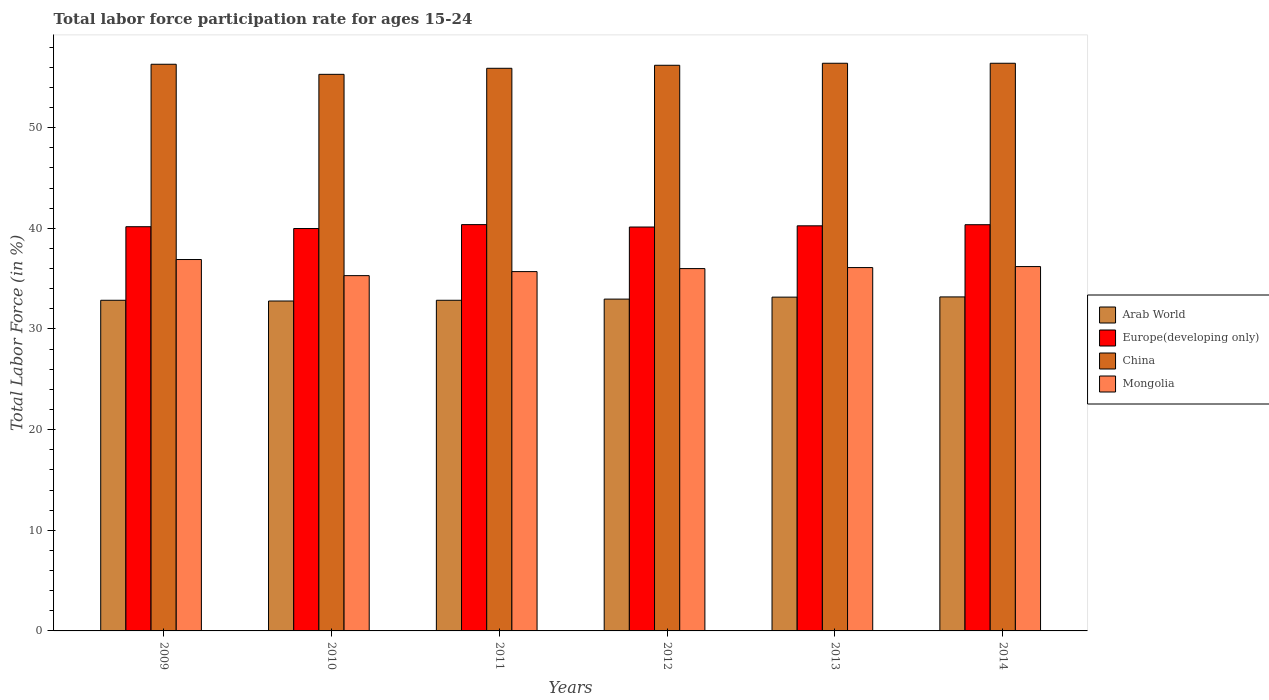How many different coloured bars are there?
Keep it short and to the point. 4. Are the number of bars on each tick of the X-axis equal?
Make the answer very short. Yes. How many bars are there on the 3rd tick from the left?
Keep it short and to the point. 4. What is the labor force participation rate in China in 2010?
Make the answer very short. 55.3. Across all years, what is the maximum labor force participation rate in Mongolia?
Ensure brevity in your answer.  36.9. Across all years, what is the minimum labor force participation rate in Mongolia?
Your response must be concise. 35.3. In which year was the labor force participation rate in China minimum?
Provide a succinct answer. 2010. What is the total labor force participation rate in China in the graph?
Make the answer very short. 336.5. What is the difference between the labor force participation rate in Europe(developing only) in 2009 and that in 2013?
Your response must be concise. -0.09. What is the difference between the labor force participation rate in Arab World in 2010 and the labor force participation rate in Europe(developing only) in 2012?
Provide a succinct answer. -7.35. What is the average labor force participation rate in Europe(developing only) per year?
Offer a very short reply. 40.21. In the year 2014, what is the difference between the labor force participation rate in Mongolia and labor force participation rate in Arab World?
Keep it short and to the point. 3.01. In how many years, is the labor force participation rate in Arab World greater than 14 %?
Make the answer very short. 6. What is the ratio of the labor force participation rate in Europe(developing only) in 2012 to that in 2013?
Keep it short and to the point. 1. Is the difference between the labor force participation rate in Mongolia in 2009 and 2012 greater than the difference between the labor force participation rate in Arab World in 2009 and 2012?
Make the answer very short. Yes. What is the difference between the highest and the second highest labor force participation rate in Europe(developing only)?
Provide a succinct answer. 0.01. What is the difference between the highest and the lowest labor force participation rate in Arab World?
Provide a short and direct response. 0.41. Is the sum of the labor force participation rate in Arab World in 2012 and 2014 greater than the maximum labor force participation rate in Europe(developing only) across all years?
Provide a short and direct response. Yes. What does the 3rd bar from the left in 2012 represents?
Offer a terse response. China. What does the 3rd bar from the right in 2013 represents?
Make the answer very short. Europe(developing only). How many bars are there?
Your response must be concise. 24. What is the title of the graph?
Give a very brief answer. Total labor force participation rate for ages 15-24. Does "Costa Rica" appear as one of the legend labels in the graph?
Offer a terse response. No. What is the label or title of the Y-axis?
Provide a succinct answer. Total Labor Force (in %). What is the Total Labor Force (in %) of Arab World in 2009?
Your answer should be compact. 32.85. What is the Total Labor Force (in %) of Europe(developing only) in 2009?
Make the answer very short. 40.16. What is the Total Labor Force (in %) in China in 2009?
Give a very brief answer. 56.3. What is the Total Labor Force (in %) of Mongolia in 2009?
Provide a succinct answer. 36.9. What is the Total Labor Force (in %) in Arab World in 2010?
Keep it short and to the point. 32.78. What is the Total Labor Force (in %) in Europe(developing only) in 2010?
Your answer should be very brief. 39.98. What is the Total Labor Force (in %) of China in 2010?
Your answer should be compact. 55.3. What is the Total Labor Force (in %) of Mongolia in 2010?
Provide a short and direct response. 35.3. What is the Total Labor Force (in %) of Arab World in 2011?
Ensure brevity in your answer.  32.85. What is the Total Labor Force (in %) of Europe(developing only) in 2011?
Ensure brevity in your answer.  40.37. What is the Total Labor Force (in %) of China in 2011?
Your answer should be compact. 55.9. What is the Total Labor Force (in %) of Mongolia in 2011?
Provide a succinct answer. 35.7. What is the Total Labor Force (in %) in Arab World in 2012?
Your response must be concise. 32.97. What is the Total Labor Force (in %) in Europe(developing only) in 2012?
Your answer should be very brief. 40.13. What is the Total Labor Force (in %) of China in 2012?
Your answer should be compact. 56.2. What is the Total Labor Force (in %) in Arab World in 2013?
Give a very brief answer. 33.16. What is the Total Labor Force (in %) of Europe(developing only) in 2013?
Ensure brevity in your answer.  40.25. What is the Total Labor Force (in %) in China in 2013?
Keep it short and to the point. 56.4. What is the Total Labor Force (in %) in Mongolia in 2013?
Make the answer very short. 36.1. What is the Total Labor Force (in %) of Arab World in 2014?
Make the answer very short. 33.19. What is the Total Labor Force (in %) of Europe(developing only) in 2014?
Provide a short and direct response. 40.36. What is the Total Labor Force (in %) of China in 2014?
Provide a short and direct response. 56.4. What is the Total Labor Force (in %) in Mongolia in 2014?
Give a very brief answer. 36.2. Across all years, what is the maximum Total Labor Force (in %) of Arab World?
Give a very brief answer. 33.19. Across all years, what is the maximum Total Labor Force (in %) in Europe(developing only)?
Give a very brief answer. 40.37. Across all years, what is the maximum Total Labor Force (in %) in China?
Provide a succinct answer. 56.4. Across all years, what is the maximum Total Labor Force (in %) in Mongolia?
Keep it short and to the point. 36.9. Across all years, what is the minimum Total Labor Force (in %) in Arab World?
Offer a terse response. 32.78. Across all years, what is the minimum Total Labor Force (in %) in Europe(developing only)?
Give a very brief answer. 39.98. Across all years, what is the minimum Total Labor Force (in %) in China?
Give a very brief answer. 55.3. Across all years, what is the minimum Total Labor Force (in %) of Mongolia?
Give a very brief answer. 35.3. What is the total Total Labor Force (in %) in Arab World in the graph?
Keep it short and to the point. 197.8. What is the total Total Labor Force (in %) of Europe(developing only) in the graph?
Give a very brief answer. 241.25. What is the total Total Labor Force (in %) of China in the graph?
Keep it short and to the point. 336.5. What is the total Total Labor Force (in %) in Mongolia in the graph?
Keep it short and to the point. 216.2. What is the difference between the Total Labor Force (in %) in Arab World in 2009 and that in 2010?
Ensure brevity in your answer.  0.07. What is the difference between the Total Labor Force (in %) of Europe(developing only) in 2009 and that in 2010?
Provide a succinct answer. 0.18. What is the difference between the Total Labor Force (in %) in China in 2009 and that in 2010?
Your answer should be very brief. 1. What is the difference between the Total Labor Force (in %) in Mongolia in 2009 and that in 2010?
Your response must be concise. 1.6. What is the difference between the Total Labor Force (in %) in Arab World in 2009 and that in 2011?
Provide a short and direct response. 0. What is the difference between the Total Labor Force (in %) of Europe(developing only) in 2009 and that in 2011?
Your response must be concise. -0.21. What is the difference between the Total Labor Force (in %) in Arab World in 2009 and that in 2012?
Offer a very short reply. -0.12. What is the difference between the Total Labor Force (in %) of Europe(developing only) in 2009 and that in 2012?
Your answer should be compact. 0.03. What is the difference between the Total Labor Force (in %) of China in 2009 and that in 2012?
Your answer should be compact. 0.1. What is the difference between the Total Labor Force (in %) in Mongolia in 2009 and that in 2012?
Ensure brevity in your answer.  0.9. What is the difference between the Total Labor Force (in %) of Arab World in 2009 and that in 2013?
Offer a very short reply. -0.31. What is the difference between the Total Labor Force (in %) of Europe(developing only) in 2009 and that in 2013?
Offer a terse response. -0.09. What is the difference between the Total Labor Force (in %) of Arab World in 2009 and that in 2014?
Give a very brief answer. -0.33. What is the difference between the Total Labor Force (in %) of Europe(developing only) in 2009 and that in 2014?
Offer a terse response. -0.2. What is the difference between the Total Labor Force (in %) in Arab World in 2010 and that in 2011?
Give a very brief answer. -0.07. What is the difference between the Total Labor Force (in %) in Europe(developing only) in 2010 and that in 2011?
Give a very brief answer. -0.39. What is the difference between the Total Labor Force (in %) in Mongolia in 2010 and that in 2011?
Provide a succinct answer. -0.4. What is the difference between the Total Labor Force (in %) in Arab World in 2010 and that in 2012?
Your response must be concise. -0.19. What is the difference between the Total Labor Force (in %) in Europe(developing only) in 2010 and that in 2012?
Keep it short and to the point. -0.15. What is the difference between the Total Labor Force (in %) in China in 2010 and that in 2012?
Provide a short and direct response. -0.9. What is the difference between the Total Labor Force (in %) of Mongolia in 2010 and that in 2012?
Make the answer very short. -0.7. What is the difference between the Total Labor Force (in %) of Arab World in 2010 and that in 2013?
Provide a short and direct response. -0.39. What is the difference between the Total Labor Force (in %) of Europe(developing only) in 2010 and that in 2013?
Provide a succinct answer. -0.27. What is the difference between the Total Labor Force (in %) in Arab World in 2010 and that in 2014?
Make the answer very short. -0.41. What is the difference between the Total Labor Force (in %) in Europe(developing only) in 2010 and that in 2014?
Your response must be concise. -0.38. What is the difference between the Total Labor Force (in %) of Mongolia in 2010 and that in 2014?
Keep it short and to the point. -0.9. What is the difference between the Total Labor Force (in %) in Arab World in 2011 and that in 2012?
Your answer should be compact. -0.12. What is the difference between the Total Labor Force (in %) in Europe(developing only) in 2011 and that in 2012?
Offer a terse response. 0.24. What is the difference between the Total Labor Force (in %) of Arab World in 2011 and that in 2013?
Make the answer very short. -0.31. What is the difference between the Total Labor Force (in %) of Europe(developing only) in 2011 and that in 2013?
Ensure brevity in your answer.  0.12. What is the difference between the Total Labor Force (in %) of China in 2011 and that in 2013?
Your answer should be compact. -0.5. What is the difference between the Total Labor Force (in %) of Arab World in 2011 and that in 2014?
Give a very brief answer. -0.33. What is the difference between the Total Labor Force (in %) of Europe(developing only) in 2011 and that in 2014?
Your answer should be compact. 0.01. What is the difference between the Total Labor Force (in %) in Mongolia in 2011 and that in 2014?
Provide a succinct answer. -0.5. What is the difference between the Total Labor Force (in %) in Arab World in 2012 and that in 2013?
Give a very brief answer. -0.2. What is the difference between the Total Labor Force (in %) in Europe(developing only) in 2012 and that in 2013?
Offer a terse response. -0.12. What is the difference between the Total Labor Force (in %) in China in 2012 and that in 2013?
Ensure brevity in your answer.  -0.2. What is the difference between the Total Labor Force (in %) in Arab World in 2012 and that in 2014?
Ensure brevity in your answer.  -0.22. What is the difference between the Total Labor Force (in %) in Europe(developing only) in 2012 and that in 2014?
Keep it short and to the point. -0.23. What is the difference between the Total Labor Force (in %) of Arab World in 2013 and that in 2014?
Offer a terse response. -0.02. What is the difference between the Total Labor Force (in %) of Europe(developing only) in 2013 and that in 2014?
Give a very brief answer. -0.11. What is the difference between the Total Labor Force (in %) of China in 2013 and that in 2014?
Keep it short and to the point. 0. What is the difference between the Total Labor Force (in %) in Arab World in 2009 and the Total Labor Force (in %) in Europe(developing only) in 2010?
Keep it short and to the point. -7.13. What is the difference between the Total Labor Force (in %) of Arab World in 2009 and the Total Labor Force (in %) of China in 2010?
Provide a succinct answer. -22.45. What is the difference between the Total Labor Force (in %) of Arab World in 2009 and the Total Labor Force (in %) of Mongolia in 2010?
Provide a short and direct response. -2.45. What is the difference between the Total Labor Force (in %) in Europe(developing only) in 2009 and the Total Labor Force (in %) in China in 2010?
Give a very brief answer. -15.14. What is the difference between the Total Labor Force (in %) in Europe(developing only) in 2009 and the Total Labor Force (in %) in Mongolia in 2010?
Offer a terse response. 4.86. What is the difference between the Total Labor Force (in %) in Arab World in 2009 and the Total Labor Force (in %) in Europe(developing only) in 2011?
Offer a terse response. -7.52. What is the difference between the Total Labor Force (in %) in Arab World in 2009 and the Total Labor Force (in %) in China in 2011?
Provide a succinct answer. -23.05. What is the difference between the Total Labor Force (in %) in Arab World in 2009 and the Total Labor Force (in %) in Mongolia in 2011?
Your answer should be very brief. -2.85. What is the difference between the Total Labor Force (in %) in Europe(developing only) in 2009 and the Total Labor Force (in %) in China in 2011?
Provide a short and direct response. -15.74. What is the difference between the Total Labor Force (in %) of Europe(developing only) in 2009 and the Total Labor Force (in %) of Mongolia in 2011?
Keep it short and to the point. 4.46. What is the difference between the Total Labor Force (in %) in China in 2009 and the Total Labor Force (in %) in Mongolia in 2011?
Provide a succinct answer. 20.6. What is the difference between the Total Labor Force (in %) in Arab World in 2009 and the Total Labor Force (in %) in Europe(developing only) in 2012?
Your answer should be compact. -7.28. What is the difference between the Total Labor Force (in %) in Arab World in 2009 and the Total Labor Force (in %) in China in 2012?
Offer a terse response. -23.35. What is the difference between the Total Labor Force (in %) of Arab World in 2009 and the Total Labor Force (in %) of Mongolia in 2012?
Your response must be concise. -3.15. What is the difference between the Total Labor Force (in %) of Europe(developing only) in 2009 and the Total Labor Force (in %) of China in 2012?
Offer a very short reply. -16.04. What is the difference between the Total Labor Force (in %) in Europe(developing only) in 2009 and the Total Labor Force (in %) in Mongolia in 2012?
Your answer should be compact. 4.16. What is the difference between the Total Labor Force (in %) in China in 2009 and the Total Labor Force (in %) in Mongolia in 2012?
Your response must be concise. 20.3. What is the difference between the Total Labor Force (in %) in Arab World in 2009 and the Total Labor Force (in %) in Europe(developing only) in 2013?
Offer a very short reply. -7.4. What is the difference between the Total Labor Force (in %) in Arab World in 2009 and the Total Labor Force (in %) in China in 2013?
Make the answer very short. -23.55. What is the difference between the Total Labor Force (in %) in Arab World in 2009 and the Total Labor Force (in %) in Mongolia in 2013?
Your response must be concise. -3.25. What is the difference between the Total Labor Force (in %) of Europe(developing only) in 2009 and the Total Labor Force (in %) of China in 2013?
Keep it short and to the point. -16.24. What is the difference between the Total Labor Force (in %) in Europe(developing only) in 2009 and the Total Labor Force (in %) in Mongolia in 2013?
Provide a short and direct response. 4.06. What is the difference between the Total Labor Force (in %) of China in 2009 and the Total Labor Force (in %) of Mongolia in 2013?
Make the answer very short. 20.2. What is the difference between the Total Labor Force (in %) in Arab World in 2009 and the Total Labor Force (in %) in Europe(developing only) in 2014?
Make the answer very short. -7.51. What is the difference between the Total Labor Force (in %) in Arab World in 2009 and the Total Labor Force (in %) in China in 2014?
Give a very brief answer. -23.55. What is the difference between the Total Labor Force (in %) in Arab World in 2009 and the Total Labor Force (in %) in Mongolia in 2014?
Provide a short and direct response. -3.35. What is the difference between the Total Labor Force (in %) in Europe(developing only) in 2009 and the Total Labor Force (in %) in China in 2014?
Your answer should be very brief. -16.24. What is the difference between the Total Labor Force (in %) of Europe(developing only) in 2009 and the Total Labor Force (in %) of Mongolia in 2014?
Ensure brevity in your answer.  3.96. What is the difference between the Total Labor Force (in %) in China in 2009 and the Total Labor Force (in %) in Mongolia in 2014?
Ensure brevity in your answer.  20.1. What is the difference between the Total Labor Force (in %) of Arab World in 2010 and the Total Labor Force (in %) of Europe(developing only) in 2011?
Your answer should be compact. -7.59. What is the difference between the Total Labor Force (in %) of Arab World in 2010 and the Total Labor Force (in %) of China in 2011?
Offer a very short reply. -23.12. What is the difference between the Total Labor Force (in %) of Arab World in 2010 and the Total Labor Force (in %) of Mongolia in 2011?
Keep it short and to the point. -2.92. What is the difference between the Total Labor Force (in %) of Europe(developing only) in 2010 and the Total Labor Force (in %) of China in 2011?
Your answer should be very brief. -15.92. What is the difference between the Total Labor Force (in %) of Europe(developing only) in 2010 and the Total Labor Force (in %) of Mongolia in 2011?
Ensure brevity in your answer.  4.28. What is the difference between the Total Labor Force (in %) of China in 2010 and the Total Labor Force (in %) of Mongolia in 2011?
Offer a terse response. 19.6. What is the difference between the Total Labor Force (in %) of Arab World in 2010 and the Total Labor Force (in %) of Europe(developing only) in 2012?
Make the answer very short. -7.35. What is the difference between the Total Labor Force (in %) in Arab World in 2010 and the Total Labor Force (in %) in China in 2012?
Your answer should be compact. -23.42. What is the difference between the Total Labor Force (in %) in Arab World in 2010 and the Total Labor Force (in %) in Mongolia in 2012?
Offer a terse response. -3.22. What is the difference between the Total Labor Force (in %) in Europe(developing only) in 2010 and the Total Labor Force (in %) in China in 2012?
Your answer should be compact. -16.22. What is the difference between the Total Labor Force (in %) in Europe(developing only) in 2010 and the Total Labor Force (in %) in Mongolia in 2012?
Ensure brevity in your answer.  3.98. What is the difference between the Total Labor Force (in %) in China in 2010 and the Total Labor Force (in %) in Mongolia in 2012?
Your answer should be compact. 19.3. What is the difference between the Total Labor Force (in %) in Arab World in 2010 and the Total Labor Force (in %) in Europe(developing only) in 2013?
Offer a very short reply. -7.47. What is the difference between the Total Labor Force (in %) of Arab World in 2010 and the Total Labor Force (in %) of China in 2013?
Keep it short and to the point. -23.62. What is the difference between the Total Labor Force (in %) of Arab World in 2010 and the Total Labor Force (in %) of Mongolia in 2013?
Offer a terse response. -3.32. What is the difference between the Total Labor Force (in %) in Europe(developing only) in 2010 and the Total Labor Force (in %) in China in 2013?
Offer a terse response. -16.42. What is the difference between the Total Labor Force (in %) in Europe(developing only) in 2010 and the Total Labor Force (in %) in Mongolia in 2013?
Offer a terse response. 3.88. What is the difference between the Total Labor Force (in %) in China in 2010 and the Total Labor Force (in %) in Mongolia in 2013?
Provide a succinct answer. 19.2. What is the difference between the Total Labor Force (in %) of Arab World in 2010 and the Total Labor Force (in %) of Europe(developing only) in 2014?
Your answer should be very brief. -7.58. What is the difference between the Total Labor Force (in %) in Arab World in 2010 and the Total Labor Force (in %) in China in 2014?
Offer a very short reply. -23.62. What is the difference between the Total Labor Force (in %) in Arab World in 2010 and the Total Labor Force (in %) in Mongolia in 2014?
Your answer should be compact. -3.42. What is the difference between the Total Labor Force (in %) in Europe(developing only) in 2010 and the Total Labor Force (in %) in China in 2014?
Offer a terse response. -16.42. What is the difference between the Total Labor Force (in %) of Europe(developing only) in 2010 and the Total Labor Force (in %) of Mongolia in 2014?
Offer a terse response. 3.78. What is the difference between the Total Labor Force (in %) of Arab World in 2011 and the Total Labor Force (in %) of Europe(developing only) in 2012?
Your answer should be compact. -7.28. What is the difference between the Total Labor Force (in %) in Arab World in 2011 and the Total Labor Force (in %) in China in 2012?
Provide a succinct answer. -23.35. What is the difference between the Total Labor Force (in %) of Arab World in 2011 and the Total Labor Force (in %) of Mongolia in 2012?
Provide a short and direct response. -3.15. What is the difference between the Total Labor Force (in %) of Europe(developing only) in 2011 and the Total Labor Force (in %) of China in 2012?
Your response must be concise. -15.83. What is the difference between the Total Labor Force (in %) of Europe(developing only) in 2011 and the Total Labor Force (in %) of Mongolia in 2012?
Provide a succinct answer. 4.37. What is the difference between the Total Labor Force (in %) of Arab World in 2011 and the Total Labor Force (in %) of Europe(developing only) in 2013?
Make the answer very short. -7.4. What is the difference between the Total Labor Force (in %) in Arab World in 2011 and the Total Labor Force (in %) in China in 2013?
Provide a short and direct response. -23.55. What is the difference between the Total Labor Force (in %) of Arab World in 2011 and the Total Labor Force (in %) of Mongolia in 2013?
Keep it short and to the point. -3.25. What is the difference between the Total Labor Force (in %) of Europe(developing only) in 2011 and the Total Labor Force (in %) of China in 2013?
Give a very brief answer. -16.03. What is the difference between the Total Labor Force (in %) of Europe(developing only) in 2011 and the Total Labor Force (in %) of Mongolia in 2013?
Make the answer very short. 4.27. What is the difference between the Total Labor Force (in %) of China in 2011 and the Total Labor Force (in %) of Mongolia in 2013?
Keep it short and to the point. 19.8. What is the difference between the Total Labor Force (in %) in Arab World in 2011 and the Total Labor Force (in %) in Europe(developing only) in 2014?
Keep it short and to the point. -7.51. What is the difference between the Total Labor Force (in %) in Arab World in 2011 and the Total Labor Force (in %) in China in 2014?
Ensure brevity in your answer.  -23.55. What is the difference between the Total Labor Force (in %) of Arab World in 2011 and the Total Labor Force (in %) of Mongolia in 2014?
Offer a terse response. -3.35. What is the difference between the Total Labor Force (in %) in Europe(developing only) in 2011 and the Total Labor Force (in %) in China in 2014?
Your response must be concise. -16.03. What is the difference between the Total Labor Force (in %) in Europe(developing only) in 2011 and the Total Labor Force (in %) in Mongolia in 2014?
Ensure brevity in your answer.  4.17. What is the difference between the Total Labor Force (in %) in China in 2011 and the Total Labor Force (in %) in Mongolia in 2014?
Provide a succinct answer. 19.7. What is the difference between the Total Labor Force (in %) in Arab World in 2012 and the Total Labor Force (in %) in Europe(developing only) in 2013?
Offer a terse response. -7.28. What is the difference between the Total Labor Force (in %) of Arab World in 2012 and the Total Labor Force (in %) of China in 2013?
Give a very brief answer. -23.43. What is the difference between the Total Labor Force (in %) of Arab World in 2012 and the Total Labor Force (in %) of Mongolia in 2013?
Offer a very short reply. -3.13. What is the difference between the Total Labor Force (in %) in Europe(developing only) in 2012 and the Total Labor Force (in %) in China in 2013?
Offer a terse response. -16.27. What is the difference between the Total Labor Force (in %) in Europe(developing only) in 2012 and the Total Labor Force (in %) in Mongolia in 2013?
Your response must be concise. 4.03. What is the difference between the Total Labor Force (in %) in China in 2012 and the Total Labor Force (in %) in Mongolia in 2013?
Provide a short and direct response. 20.1. What is the difference between the Total Labor Force (in %) of Arab World in 2012 and the Total Labor Force (in %) of Europe(developing only) in 2014?
Keep it short and to the point. -7.39. What is the difference between the Total Labor Force (in %) of Arab World in 2012 and the Total Labor Force (in %) of China in 2014?
Make the answer very short. -23.43. What is the difference between the Total Labor Force (in %) of Arab World in 2012 and the Total Labor Force (in %) of Mongolia in 2014?
Your answer should be very brief. -3.23. What is the difference between the Total Labor Force (in %) in Europe(developing only) in 2012 and the Total Labor Force (in %) in China in 2014?
Provide a short and direct response. -16.27. What is the difference between the Total Labor Force (in %) of Europe(developing only) in 2012 and the Total Labor Force (in %) of Mongolia in 2014?
Provide a succinct answer. 3.93. What is the difference between the Total Labor Force (in %) of Arab World in 2013 and the Total Labor Force (in %) of Europe(developing only) in 2014?
Offer a very short reply. -7.19. What is the difference between the Total Labor Force (in %) of Arab World in 2013 and the Total Labor Force (in %) of China in 2014?
Provide a succinct answer. -23.24. What is the difference between the Total Labor Force (in %) of Arab World in 2013 and the Total Labor Force (in %) of Mongolia in 2014?
Ensure brevity in your answer.  -3.04. What is the difference between the Total Labor Force (in %) of Europe(developing only) in 2013 and the Total Labor Force (in %) of China in 2014?
Keep it short and to the point. -16.15. What is the difference between the Total Labor Force (in %) in Europe(developing only) in 2013 and the Total Labor Force (in %) in Mongolia in 2014?
Your answer should be very brief. 4.05. What is the difference between the Total Labor Force (in %) in China in 2013 and the Total Labor Force (in %) in Mongolia in 2014?
Your response must be concise. 20.2. What is the average Total Labor Force (in %) in Arab World per year?
Your answer should be very brief. 32.97. What is the average Total Labor Force (in %) in Europe(developing only) per year?
Your answer should be compact. 40.21. What is the average Total Labor Force (in %) of China per year?
Offer a terse response. 56.08. What is the average Total Labor Force (in %) in Mongolia per year?
Keep it short and to the point. 36.03. In the year 2009, what is the difference between the Total Labor Force (in %) of Arab World and Total Labor Force (in %) of Europe(developing only)?
Your answer should be very brief. -7.31. In the year 2009, what is the difference between the Total Labor Force (in %) of Arab World and Total Labor Force (in %) of China?
Your answer should be very brief. -23.45. In the year 2009, what is the difference between the Total Labor Force (in %) of Arab World and Total Labor Force (in %) of Mongolia?
Give a very brief answer. -4.05. In the year 2009, what is the difference between the Total Labor Force (in %) of Europe(developing only) and Total Labor Force (in %) of China?
Offer a very short reply. -16.14. In the year 2009, what is the difference between the Total Labor Force (in %) in Europe(developing only) and Total Labor Force (in %) in Mongolia?
Offer a terse response. 3.26. In the year 2010, what is the difference between the Total Labor Force (in %) in Arab World and Total Labor Force (in %) in Europe(developing only)?
Ensure brevity in your answer.  -7.2. In the year 2010, what is the difference between the Total Labor Force (in %) of Arab World and Total Labor Force (in %) of China?
Your response must be concise. -22.52. In the year 2010, what is the difference between the Total Labor Force (in %) in Arab World and Total Labor Force (in %) in Mongolia?
Your answer should be very brief. -2.52. In the year 2010, what is the difference between the Total Labor Force (in %) in Europe(developing only) and Total Labor Force (in %) in China?
Make the answer very short. -15.32. In the year 2010, what is the difference between the Total Labor Force (in %) of Europe(developing only) and Total Labor Force (in %) of Mongolia?
Give a very brief answer. 4.68. In the year 2010, what is the difference between the Total Labor Force (in %) of China and Total Labor Force (in %) of Mongolia?
Provide a succinct answer. 20. In the year 2011, what is the difference between the Total Labor Force (in %) of Arab World and Total Labor Force (in %) of Europe(developing only)?
Give a very brief answer. -7.52. In the year 2011, what is the difference between the Total Labor Force (in %) in Arab World and Total Labor Force (in %) in China?
Give a very brief answer. -23.05. In the year 2011, what is the difference between the Total Labor Force (in %) in Arab World and Total Labor Force (in %) in Mongolia?
Provide a short and direct response. -2.85. In the year 2011, what is the difference between the Total Labor Force (in %) of Europe(developing only) and Total Labor Force (in %) of China?
Your answer should be compact. -15.53. In the year 2011, what is the difference between the Total Labor Force (in %) of Europe(developing only) and Total Labor Force (in %) of Mongolia?
Provide a succinct answer. 4.67. In the year 2011, what is the difference between the Total Labor Force (in %) of China and Total Labor Force (in %) of Mongolia?
Provide a succinct answer. 20.2. In the year 2012, what is the difference between the Total Labor Force (in %) in Arab World and Total Labor Force (in %) in Europe(developing only)?
Offer a very short reply. -7.16. In the year 2012, what is the difference between the Total Labor Force (in %) in Arab World and Total Labor Force (in %) in China?
Your response must be concise. -23.23. In the year 2012, what is the difference between the Total Labor Force (in %) of Arab World and Total Labor Force (in %) of Mongolia?
Ensure brevity in your answer.  -3.03. In the year 2012, what is the difference between the Total Labor Force (in %) of Europe(developing only) and Total Labor Force (in %) of China?
Your answer should be compact. -16.07. In the year 2012, what is the difference between the Total Labor Force (in %) in Europe(developing only) and Total Labor Force (in %) in Mongolia?
Offer a terse response. 4.13. In the year 2012, what is the difference between the Total Labor Force (in %) of China and Total Labor Force (in %) of Mongolia?
Make the answer very short. 20.2. In the year 2013, what is the difference between the Total Labor Force (in %) in Arab World and Total Labor Force (in %) in Europe(developing only)?
Make the answer very short. -7.09. In the year 2013, what is the difference between the Total Labor Force (in %) of Arab World and Total Labor Force (in %) of China?
Provide a succinct answer. -23.24. In the year 2013, what is the difference between the Total Labor Force (in %) of Arab World and Total Labor Force (in %) of Mongolia?
Your answer should be compact. -2.94. In the year 2013, what is the difference between the Total Labor Force (in %) of Europe(developing only) and Total Labor Force (in %) of China?
Give a very brief answer. -16.15. In the year 2013, what is the difference between the Total Labor Force (in %) in Europe(developing only) and Total Labor Force (in %) in Mongolia?
Your answer should be compact. 4.15. In the year 2013, what is the difference between the Total Labor Force (in %) of China and Total Labor Force (in %) of Mongolia?
Provide a succinct answer. 20.3. In the year 2014, what is the difference between the Total Labor Force (in %) of Arab World and Total Labor Force (in %) of Europe(developing only)?
Your answer should be very brief. -7.17. In the year 2014, what is the difference between the Total Labor Force (in %) of Arab World and Total Labor Force (in %) of China?
Your answer should be compact. -23.21. In the year 2014, what is the difference between the Total Labor Force (in %) in Arab World and Total Labor Force (in %) in Mongolia?
Your answer should be compact. -3.01. In the year 2014, what is the difference between the Total Labor Force (in %) of Europe(developing only) and Total Labor Force (in %) of China?
Provide a succinct answer. -16.04. In the year 2014, what is the difference between the Total Labor Force (in %) in Europe(developing only) and Total Labor Force (in %) in Mongolia?
Provide a succinct answer. 4.16. In the year 2014, what is the difference between the Total Labor Force (in %) in China and Total Labor Force (in %) in Mongolia?
Keep it short and to the point. 20.2. What is the ratio of the Total Labor Force (in %) in Arab World in 2009 to that in 2010?
Offer a terse response. 1. What is the ratio of the Total Labor Force (in %) of Europe(developing only) in 2009 to that in 2010?
Keep it short and to the point. 1. What is the ratio of the Total Labor Force (in %) of China in 2009 to that in 2010?
Your answer should be very brief. 1.02. What is the ratio of the Total Labor Force (in %) in Mongolia in 2009 to that in 2010?
Your answer should be compact. 1.05. What is the ratio of the Total Labor Force (in %) of Arab World in 2009 to that in 2011?
Your answer should be very brief. 1. What is the ratio of the Total Labor Force (in %) in Mongolia in 2009 to that in 2011?
Provide a short and direct response. 1.03. What is the ratio of the Total Labor Force (in %) in Arab World in 2009 to that in 2012?
Ensure brevity in your answer.  1. What is the ratio of the Total Labor Force (in %) in Europe(developing only) in 2009 to that in 2012?
Your response must be concise. 1. What is the ratio of the Total Labor Force (in %) in China in 2009 to that in 2012?
Provide a succinct answer. 1. What is the ratio of the Total Labor Force (in %) of Mongolia in 2009 to that in 2012?
Give a very brief answer. 1.02. What is the ratio of the Total Labor Force (in %) of Arab World in 2009 to that in 2013?
Offer a very short reply. 0.99. What is the ratio of the Total Labor Force (in %) in Mongolia in 2009 to that in 2013?
Provide a succinct answer. 1.02. What is the ratio of the Total Labor Force (in %) in Mongolia in 2009 to that in 2014?
Your response must be concise. 1.02. What is the ratio of the Total Labor Force (in %) in China in 2010 to that in 2011?
Your answer should be very brief. 0.99. What is the ratio of the Total Labor Force (in %) of Europe(developing only) in 2010 to that in 2012?
Your answer should be very brief. 1. What is the ratio of the Total Labor Force (in %) of China in 2010 to that in 2012?
Your answer should be compact. 0.98. What is the ratio of the Total Labor Force (in %) in Mongolia in 2010 to that in 2012?
Ensure brevity in your answer.  0.98. What is the ratio of the Total Labor Force (in %) in Arab World in 2010 to that in 2013?
Ensure brevity in your answer.  0.99. What is the ratio of the Total Labor Force (in %) of Europe(developing only) in 2010 to that in 2013?
Give a very brief answer. 0.99. What is the ratio of the Total Labor Force (in %) in China in 2010 to that in 2013?
Make the answer very short. 0.98. What is the ratio of the Total Labor Force (in %) of Mongolia in 2010 to that in 2013?
Offer a terse response. 0.98. What is the ratio of the Total Labor Force (in %) in Europe(developing only) in 2010 to that in 2014?
Keep it short and to the point. 0.99. What is the ratio of the Total Labor Force (in %) of China in 2010 to that in 2014?
Give a very brief answer. 0.98. What is the ratio of the Total Labor Force (in %) of Mongolia in 2010 to that in 2014?
Give a very brief answer. 0.98. What is the ratio of the Total Labor Force (in %) in Arab World in 2011 to that in 2012?
Make the answer very short. 1. What is the ratio of the Total Labor Force (in %) of Europe(developing only) in 2011 to that in 2012?
Offer a very short reply. 1.01. What is the ratio of the Total Labor Force (in %) in Mongolia in 2011 to that in 2012?
Ensure brevity in your answer.  0.99. What is the ratio of the Total Labor Force (in %) of Arab World in 2011 to that in 2013?
Offer a very short reply. 0.99. What is the ratio of the Total Labor Force (in %) in Europe(developing only) in 2011 to that in 2013?
Keep it short and to the point. 1. What is the ratio of the Total Labor Force (in %) of China in 2011 to that in 2013?
Provide a succinct answer. 0.99. What is the ratio of the Total Labor Force (in %) in Mongolia in 2011 to that in 2013?
Ensure brevity in your answer.  0.99. What is the ratio of the Total Labor Force (in %) of Europe(developing only) in 2011 to that in 2014?
Your response must be concise. 1. What is the ratio of the Total Labor Force (in %) in Mongolia in 2011 to that in 2014?
Keep it short and to the point. 0.99. What is the ratio of the Total Labor Force (in %) of Europe(developing only) in 2012 to that in 2013?
Provide a short and direct response. 1. What is the ratio of the Total Labor Force (in %) of China in 2012 to that in 2013?
Ensure brevity in your answer.  1. What is the ratio of the Total Labor Force (in %) of China in 2012 to that in 2014?
Provide a short and direct response. 1. What is the ratio of the Total Labor Force (in %) in Europe(developing only) in 2013 to that in 2014?
Ensure brevity in your answer.  1. What is the ratio of the Total Labor Force (in %) in China in 2013 to that in 2014?
Your response must be concise. 1. What is the ratio of the Total Labor Force (in %) of Mongolia in 2013 to that in 2014?
Your answer should be very brief. 1. What is the difference between the highest and the second highest Total Labor Force (in %) of Arab World?
Your answer should be very brief. 0.02. What is the difference between the highest and the second highest Total Labor Force (in %) of Europe(developing only)?
Ensure brevity in your answer.  0.01. What is the difference between the highest and the lowest Total Labor Force (in %) in Arab World?
Give a very brief answer. 0.41. What is the difference between the highest and the lowest Total Labor Force (in %) of Europe(developing only)?
Offer a terse response. 0.39. What is the difference between the highest and the lowest Total Labor Force (in %) in China?
Your response must be concise. 1.1. What is the difference between the highest and the lowest Total Labor Force (in %) in Mongolia?
Keep it short and to the point. 1.6. 